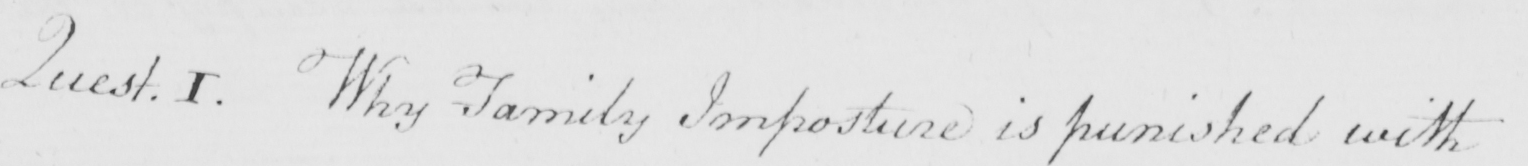Transcribe the text shown in this historical manuscript line. Quest . 1 . Why Family Imposture is punished with 